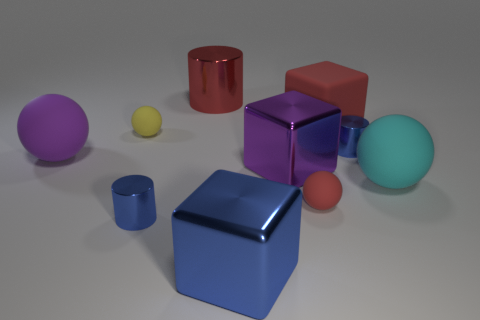How many other objects are the same color as the large matte block?
Your answer should be very brief. 2. The big metal object that is behind the large cyan thing and in front of the purple sphere has what shape?
Keep it short and to the point. Cube. Are there any red things that are on the right side of the matte sphere to the right of the blue object behind the big cyan rubber ball?
Give a very brief answer. No. What number of other objects are there of the same material as the big cylinder?
Ensure brevity in your answer.  4. What number of tiny blue cylinders are there?
Your answer should be compact. 2. How many objects are either large shiny blocks or spheres that are to the left of the large blue metallic thing?
Offer a terse response. 4. Is there any other thing that is the same shape as the big blue object?
Give a very brief answer. Yes. There is a matte object that is in front of the cyan rubber sphere; does it have the same size as the purple rubber sphere?
Make the answer very short. No. What number of matte things are tiny blue cylinders or cylinders?
Keep it short and to the point. 0. What is the size of the yellow rubber thing that is in front of the red shiny thing?
Your answer should be compact. Small. 